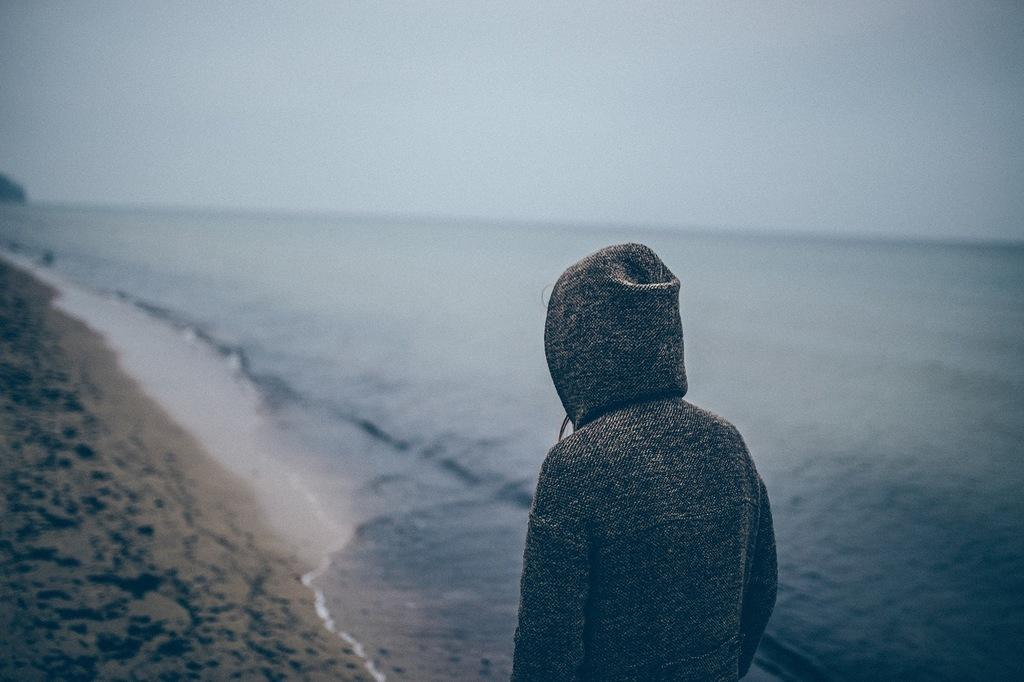Who or what is present in the image? There is a person in the image. What can be seen in the distance behind the person? There is a mountain in the background of the image. What is visible at the top of the image? The sky is visible at the top of the image. What type of terrain is at the bottom of the image? There is sand and water at the bottom of the image. What type of sign can be seen near the water in the image? There is no sign present in the image; it only features a person, a mountain, the sky, sand, and water. Is the person in the image swimming in the water? The image does not show the person swimming; it only shows them standing near the water. 